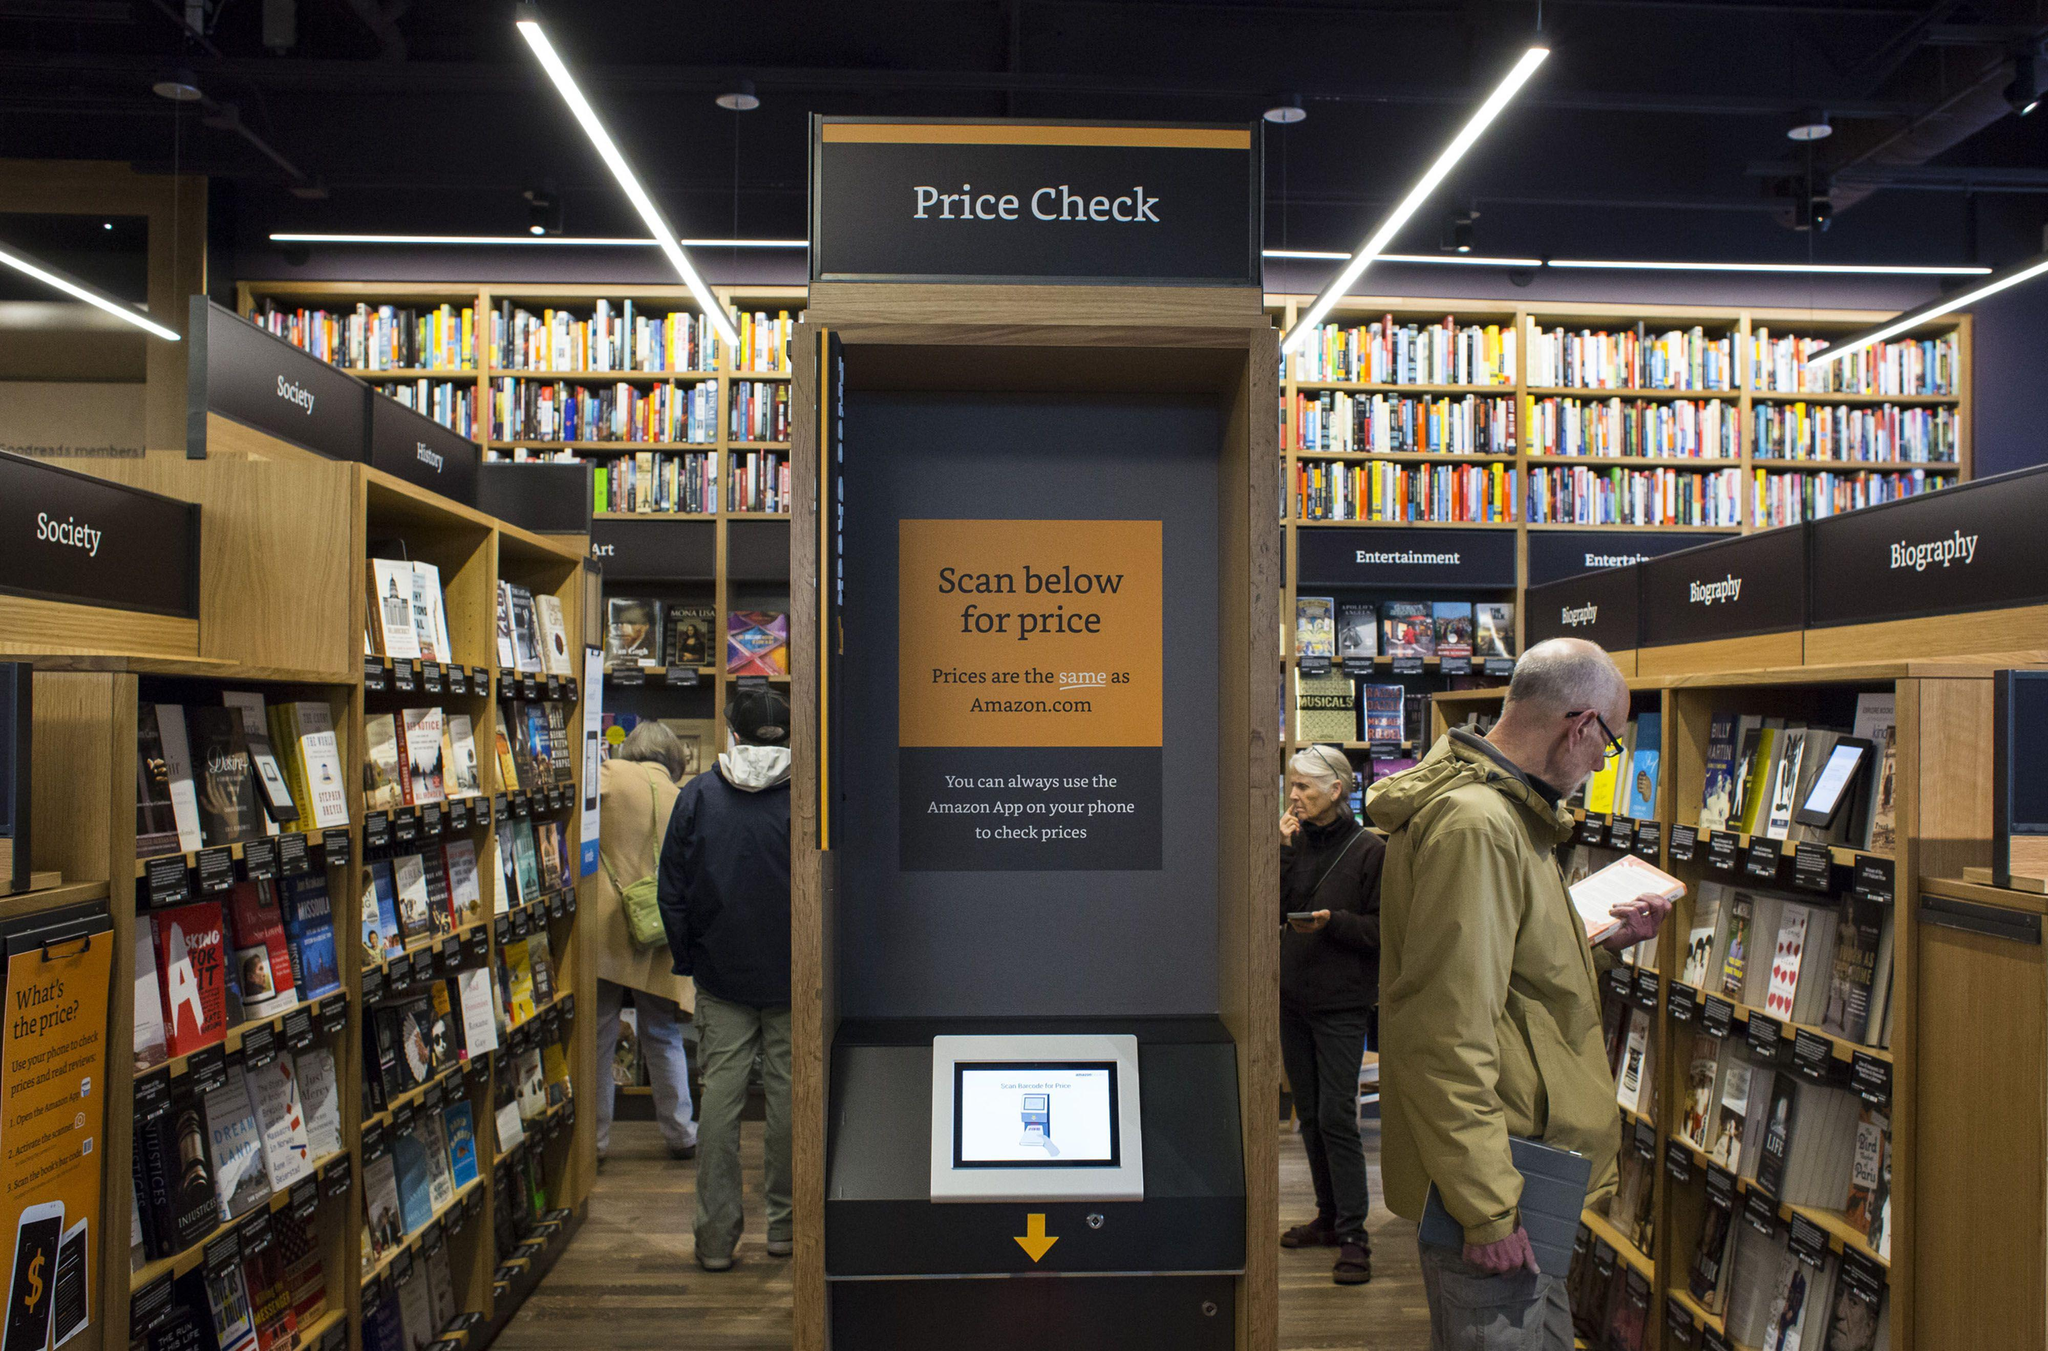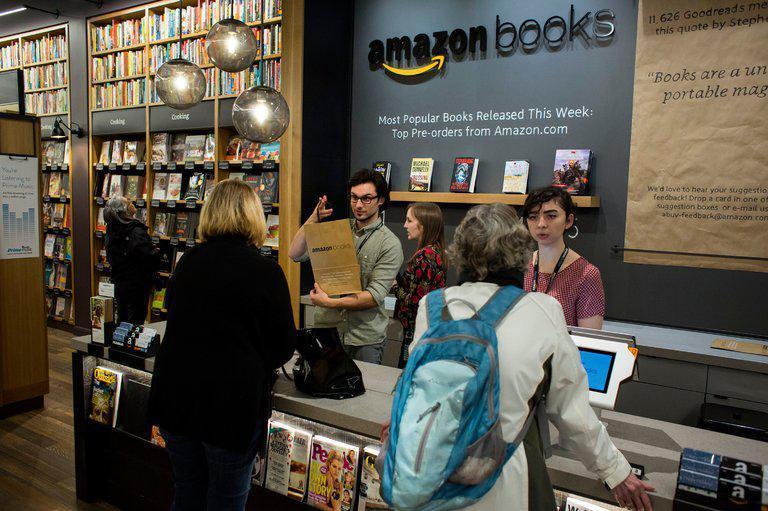The first image is the image on the left, the second image is the image on the right. Assess this claim about the two images: "There are people looking at books in the bookstore in both images.". Correct or not? Answer yes or no. Yes. 